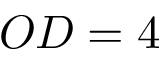Convert formula to latex. <formula><loc_0><loc_0><loc_500><loc_500>O D = 4</formula> 